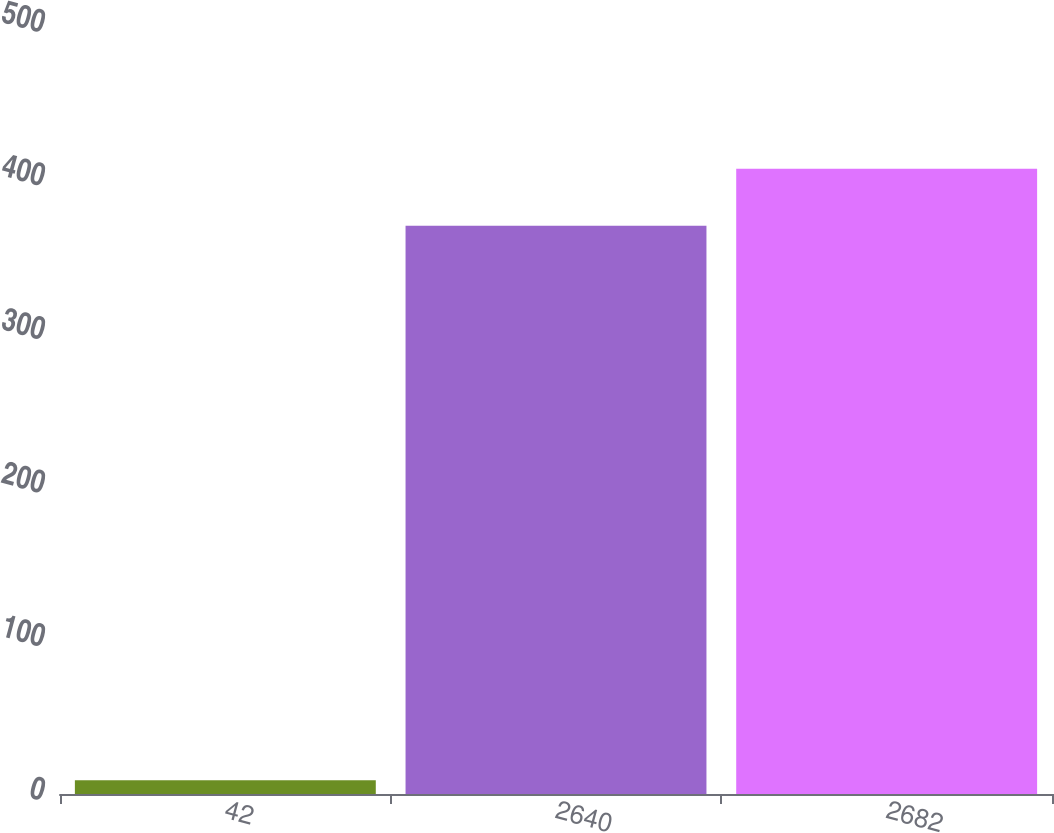<chart> <loc_0><loc_0><loc_500><loc_500><bar_chart><fcel>42<fcel>2640<fcel>2682<nl><fcel>9<fcel>370<fcel>407<nl></chart> 